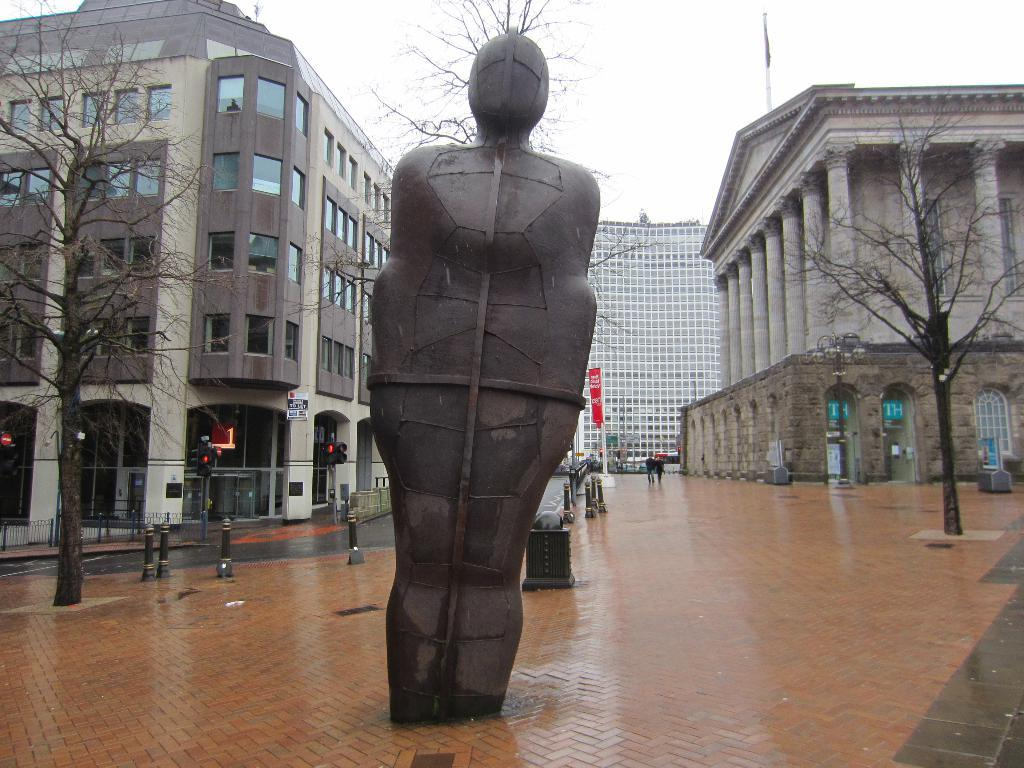What is the main subject in the image? There is a statue in the image. What can be seen in the background of the image? There are people walking, dried trees, and buildings in the background of the image. What is the color of the sky in the image? The sky is white in color. Can you hear the sneeze of the person in the image? There is no person sneezing in the image; it only shows a statue and the background elements. What type of airport can be seen in the image? There is no airport present in the image; it features a statue and the surrounding environment. 